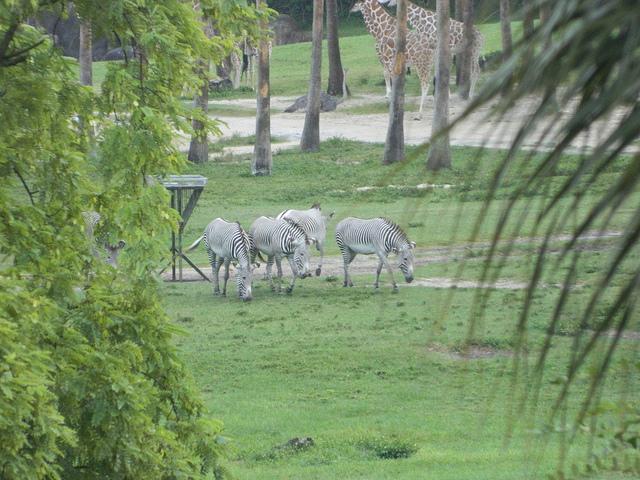Where are these Zebras most likely living together with the giraffes?
Answer the question by selecting the correct answer among the 4 following choices.
Options: Zoo, wild, house, conservatory. Conservatory. 